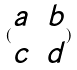<formula> <loc_0><loc_0><loc_500><loc_500>( \begin{matrix} a & b \\ c & d \end{matrix} )</formula> 